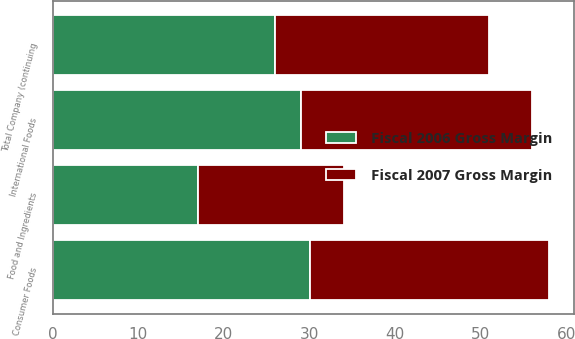Convert chart. <chart><loc_0><loc_0><loc_500><loc_500><stacked_bar_chart><ecel><fcel>Consumer Foods<fcel>Food and Ingredients<fcel>International Foods<fcel>Total Company (continuing<nl><fcel>Fiscal 2006 Gross Margin<fcel>30<fcel>17<fcel>29<fcel>26<nl><fcel>Fiscal 2007 Gross Margin<fcel>28<fcel>17<fcel>27<fcel>25<nl></chart> 